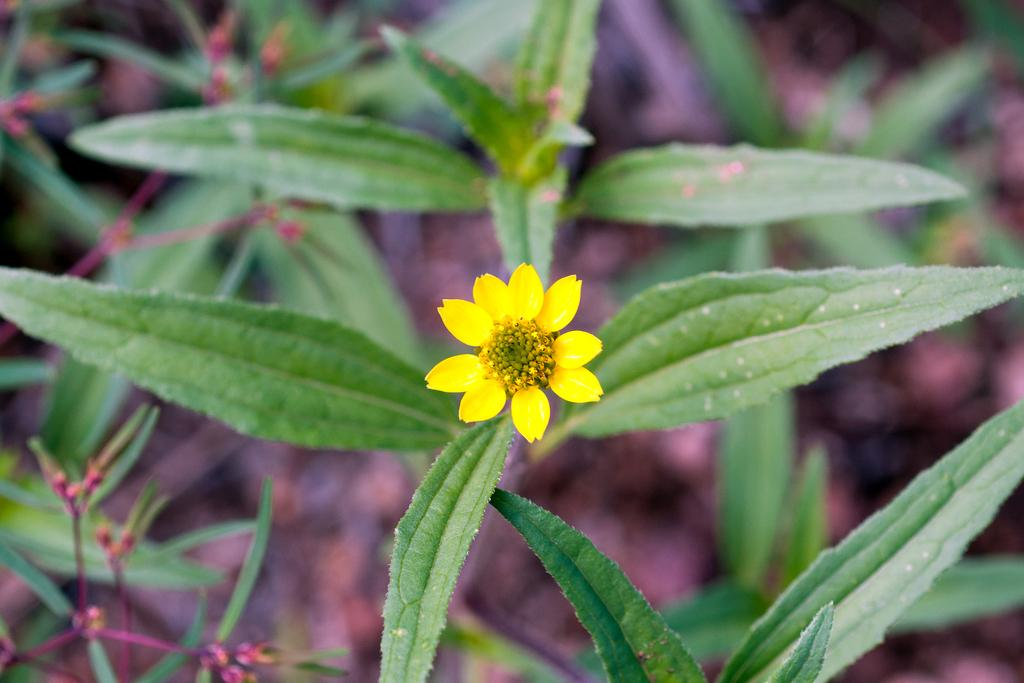What is the main subject in the front of the image? There is a flower in the front of the image. What can be seen in the background of the image? There are plants in the background of the image. What type of punishment is being given to the flower in the image? There is no punishment being given to the flower in the image; it is simply a flower in the front of the image. 